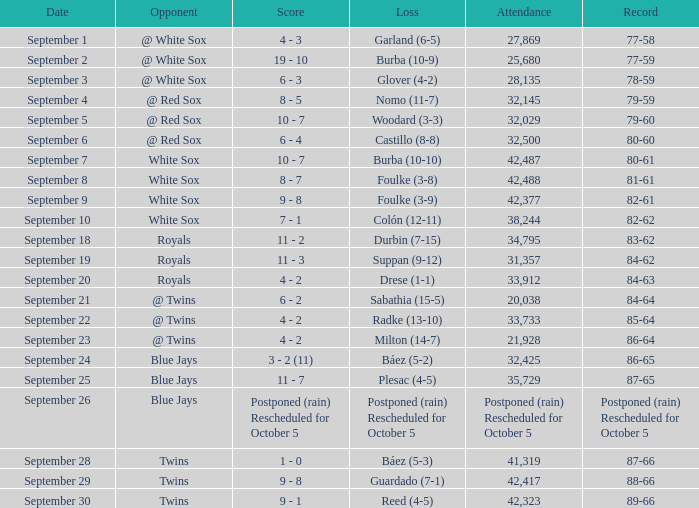With a score of 80-61, which game holds the record? 10 - 7. 